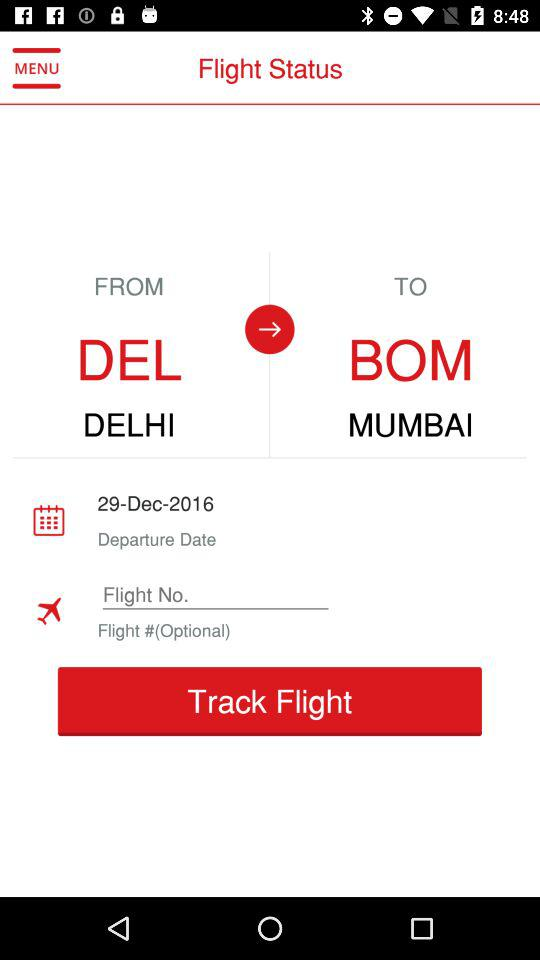What is the departure date? The departure date is December 29, 2016. 